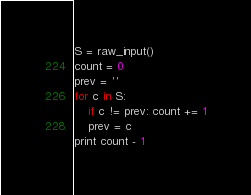<code> <loc_0><loc_0><loc_500><loc_500><_Python_>S = raw_input()
count = 0
prev = ''
for c in S:
    if c != prev: count += 1
    prev = c
print count - 1</code> 